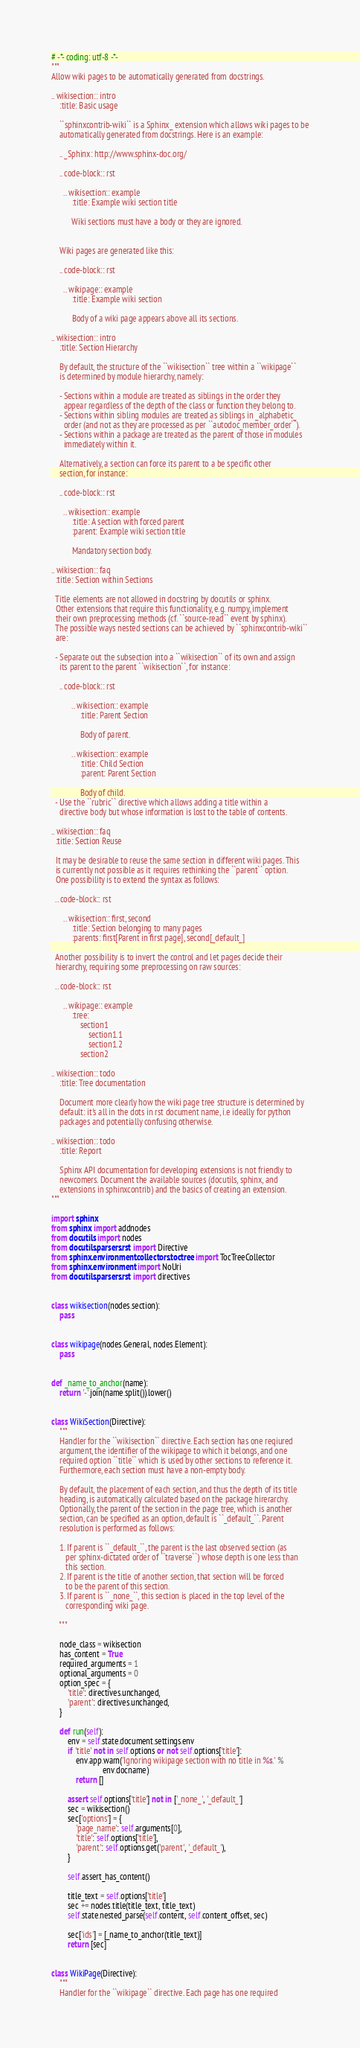<code> <loc_0><loc_0><loc_500><loc_500><_Python_># -*- coding: utf-8 -*-
"""
Allow wiki pages to be automatically generated from docstrings.

.. wikisection:: intro
    :title: Basic usage

    ``sphinxcontrib-wiki`` is a Sphinx_ extension which allows wiki pages to be
    automatically generated from docstrings. Here is an example:

    .. _Sphinx: http://www.sphinx-doc.org/

    .. code-block:: rst

      .. wikisection:: example
          :title: Example wiki section title

          Wiki sections must have a body or they are ignored.


    Wiki pages are generated like this:

    .. code-block:: rst

      .. wikipage:: example
          :title: Example wiki section

          Body of a wiki page appears above all its sections.

.. wikisection:: intro
    :title: Section Hierarchy

    By default, the structure of the ``wikisection`` tree within a ``wikipage``
    is determined by module hierarchy, namely:

    - Sections within a module are treated as siblings in the order they
      appear regardless of the depth of the class or function they belong to.
    - Sections within sibling modules are treated as siblings in _alphabetic_
      order (and not as they are processed as per ``autodoc_member_order``).
    - Sections within a package are treated as the parent of those in modules
      immediately within it.

    Alternatively, a section can force its parent to a be specific other
    section, for instance:

    .. code-block:: rst

      .. wikisection:: example
          :title: A section with forced parent
          :parent: Example wiki section title

          Mandatory section body.

.. wikisection:: faq
  :title: Section within Sections

  Title elements are not allowed in docstring by docutils or sphinx.
  Other extensions that require this functionality, e.g. numpy, implement
  their own preprocessing methods (cf. ``source-read`` event by sphinx).
  The possible ways nested sections can be achieved by ``sphinxcontrib-wiki``
  are:

  - Separate out the subsection into a ``wikisection`` of its own and assign
    its parent to the parent ``wikisection``, for instance:

    .. code-block:: rst

          .. wikisection:: example
              :title: Parent Section

              Body of parent.

          .. wikisection:: example
              :title: Child Section
              :parent: Parent Section

              Body of child.
  - Use the ``rubric`` directive which allows adding a title within a
    directive body but whose information is lost to the table of contents.

.. wikisection:: faq
  :title: Section Reuse

  It may be desirable to reuse the same section in different wiki pages. This
  is currently not possible as it requires rethinking the ``parent`` option.
  One possibility is to extend the syntax as follows:

  .. code-block:: rst

      .. wikisection:: first, second
          :title: Section belonging to many pages
          :parents: first[Parent in first page], second[_default_]

  Another possibility is to invert the control and let pages decide their
  hierarchy, requiring some preprocessing on raw sources:

  .. code-block:: rst

      .. wikipage:: example
          :tree:
              section1
                  section1.1
                  section1.2
              section2

.. wikisection:: todo
    :title: Tree documentation

    Document more clearly how the wiki page tree structure is determined by
    default: it's all in the dots in rst document name, i.e ideally for python
    packages and potentially confusing otherwise.

.. wikisection:: todo
    :title: Report

    Sphinx API documentation for developing extensions is not friendly to
    newcomers. Document the available sources (docutils, sphinx, and
    extensions in sphinxcontrib) and the basics of creating an extension.
"""

import sphinx
from sphinx import addnodes
from docutils import nodes
from docutils.parsers.rst import Directive
from sphinx.environment.collectors.toctree import TocTreeCollector
from sphinx.environment import NoUri
from docutils.parsers.rst import directives


class wikisection(nodes.section):
    pass


class wikipage(nodes.General, nodes.Element):
    pass


def _name_to_anchor(name):
    return '-'.join(name.split()).lower()


class WikiSection(Directive):
    """
    Handler for the ``wikisection`` directive. Each section has one reqiured
    argument, the identifier of the wikipage to which it belongs, and one
    required option ``title`` which is used by other sections to reference it.
    Furthermore, each section must have a non-empty body.

    By default, the placement of each section, and thus the depth of its title
    heading, is automatically calculated based on the package hirerarchy.
    Optionally, the parent of the section in the page tree, which is another
    section, can be specified as an option, default is ``_default_``. Parent
    resolution is performed as follows:

    1. If parent is ``_default_``, the parent is the last observed section (as
       per sphinx-dictated order of ``traverse``) whose depth is one less than
       this section.
    2. If parent is the title of another section, that section will be forced
       to be the parent of this section.
    3. If parent is ``_none_``, this section is placed in the top level of the
       corresponding wiki page.

    """

    node_class = wikisection
    has_content = True
    required_arguments = 1
    optional_arguments = 0
    option_spec = {
        'title': directives.unchanged,
        'parent': directives.unchanged,
    }

    def run(self):
        env = self.state.document.settings.env
        if 'title' not in self.options or not self.options['title']:
            env.app.warn('Ignoring wikipage section with no title in %s.' %
                         env.docname)
            return []

        assert self.options['title'] not in ['_none_', '_default_']
        sec = wikisection()
        sec['options'] = {
            'page_name': self.arguments[0],
            'title': self.options['title'],
            'parent': self.options.get('parent', '_default_'),
        }

        self.assert_has_content()

        title_text = self.options['title']
        sec += nodes.title(title_text, title_text)
        self.state.nested_parse(self.content, self.content_offset, sec)

        sec['ids'] = [_name_to_anchor(title_text)]
        return [sec]


class WikiPage(Directive):
    """
    Handler for the ``wikipage`` directive. Each page has one required</code> 